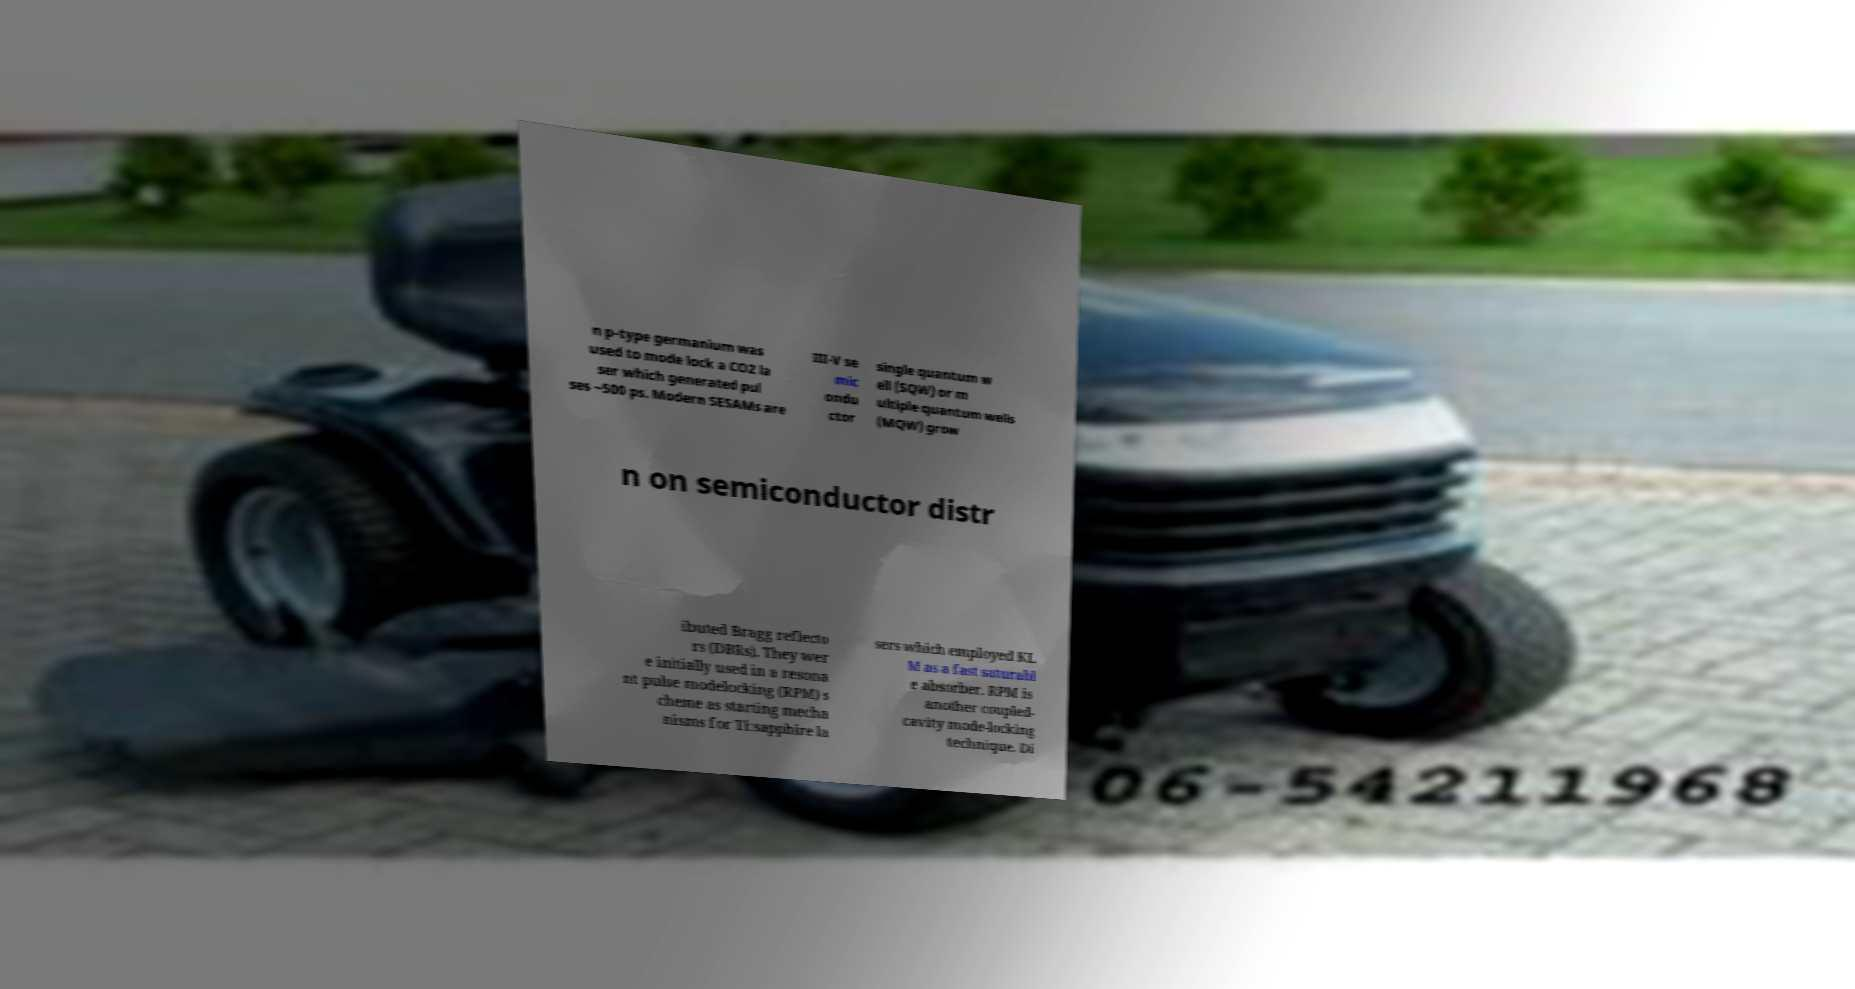Can you read and provide the text displayed in the image?This photo seems to have some interesting text. Can you extract and type it out for me? n p-type germanium was used to mode lock a CO2 la ser which generated pul ses ~500 ps. Modern SESAMs are III-V se mic ondu ctor single quantum w ell (SQW) or m ultiple quantum wells (MQW) grow n on semiconductor distr ibuted Bragg reflecto rs (DBRs). They wer e initially used in a resona nt pulse modelocking (RPM) s cheme as starting mecha nisms for Ti:sapphire la sers which employed KL M as a fast saturabl e absorber. RPM is another coupled- cavity mode-locking technique. Di 